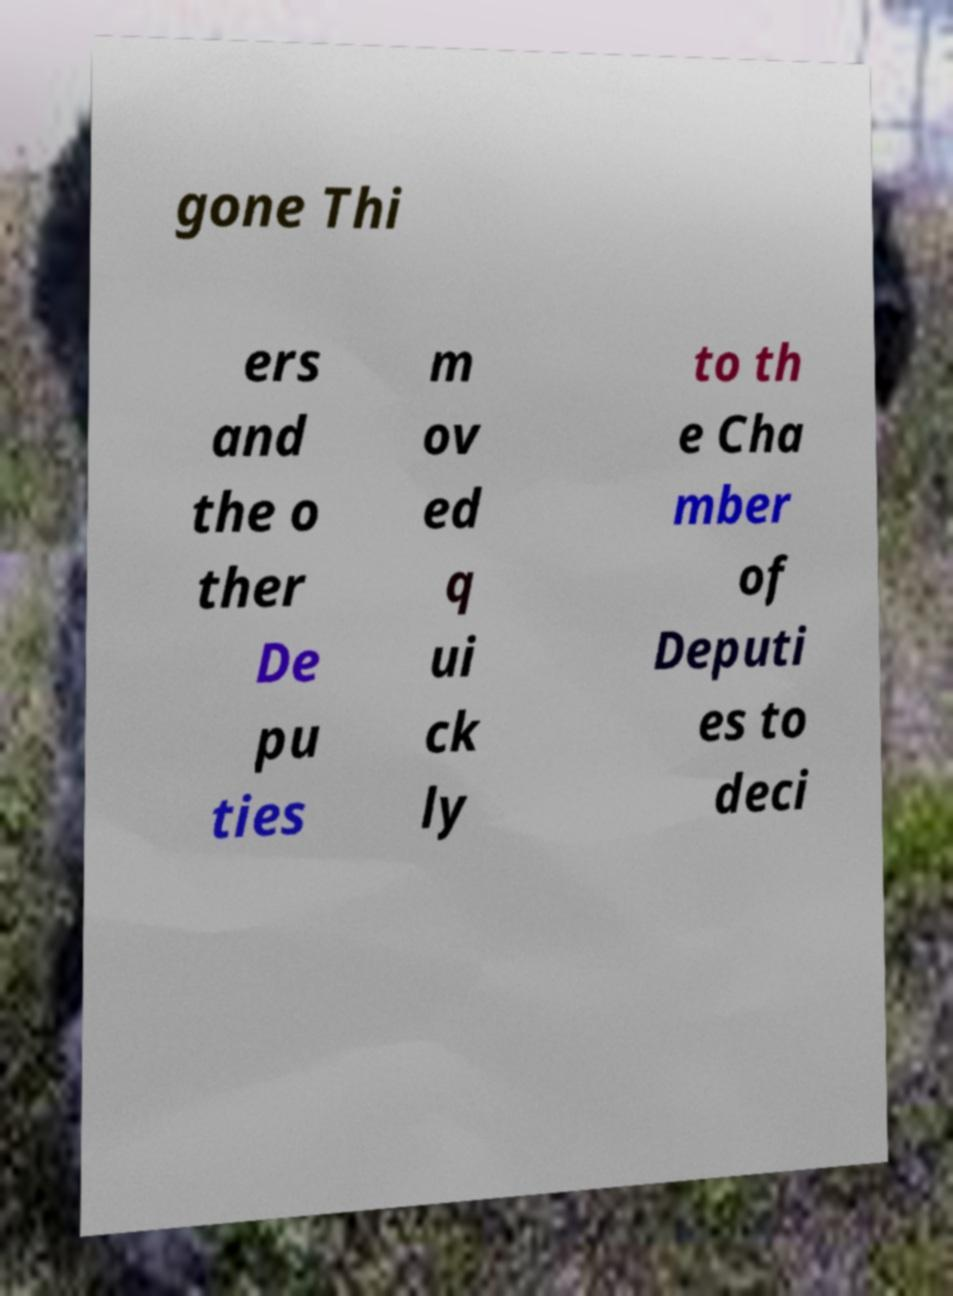Please identify and transcribe the text found in this image. gone Thi ers and the o ther De pu ties m ov ed q ui ck ly to th e Cha mber of Deputi es to deci 